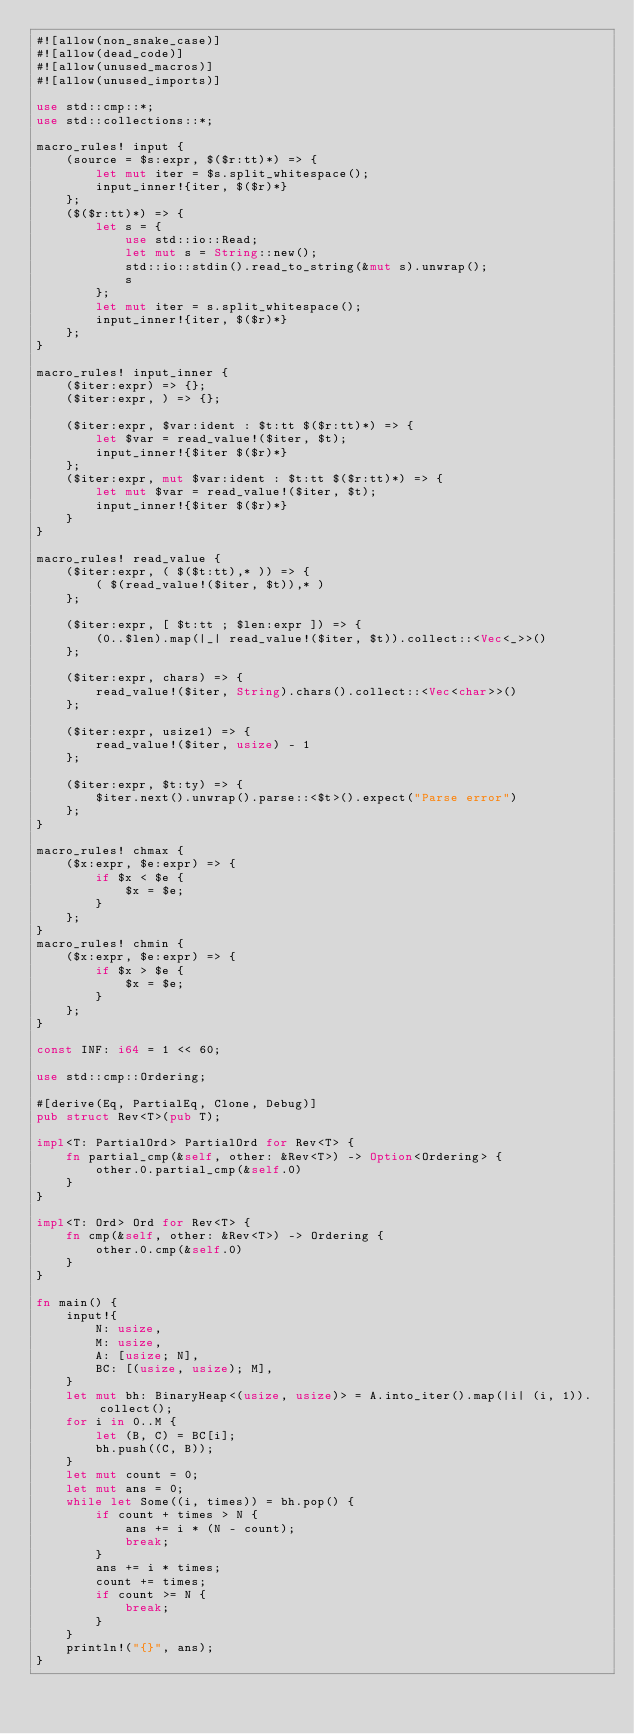<code> <loc_0><loc_0><loc_500><loc_500><_Rust_>#![allow(non_snake_case)]
#![allow(dead_code)]
#![allow(unused_macros)]
#![allow(unused_imports)]

use std::cmp::*;
use std::collections::*;

macro_rules! input {
    (source = $s:expr, $($r:tt)*) => {
        let mut iter = $s.split_whitespace();
        input_inner!{iter, $($r)*}
    };
    ($($r:tt)*) => {
        let s = {
            use std::io::Read;
            let mut s = String::new();
            std::io::stdin().read_to_string(&mut s).unwrap();
            s
        };
        let mut iter = s.split_whitespace();
        input_inner!{iter, $($r)*}
    };
}

macro_rules! input_inner {
    ($iter:expr) => {};
    ($iter:expr, ) => {};

    ($iter:expr, $var:ident : $t:tt $($r:tt)*) => {
        let $var = read_value!($iter, $t);
        input_inner!{$iter $($r)*}
    };
    ($iter:expr, mut $var:ident : $t:tt $($r:tt)*) => {
        let mut $var = read_value!($iter, $t);
        input_inner!{$iter $($r)*}
    }
}

macro_rules! read_value {
    ($iter:expr, ( $($t:tt),* )) => {
        ( $(read_value!($iter, $t)),* )
    };

    ($iter:expr, [ $t:tt ; $len:expr ]) => {
        (0..$len).map(|_| read_value!($iter, $t)).collect::<Vec<_>>()
    };

    ($iter:expr, chars) => {
        read_value!($iter, String).chars().collect::<Vec<char>>()
    };

    ($iter:expr, usize1) => {
        read_value!($iter, usize) - 1
    };

    ($iter:expr, $t:ty) => {
        $iter.next().unwrap().parse::<$t>().expect("Parse error")
    };
}

macro_rules! chmax {
    ($x:expr, $e:expr) => {
        if $x < $e {
            $x = $e;
        }
    };
}
macro_rules! chmin {
    ($x:expr, $e:expr) => {
        if $x > $e {
            $x = $e;
        }
    };
}

const INF: i64 = 1 << 60;

use std::cmp::Ordering;

#[derive(Eq, PartialEq, Clone, Debug)]
pub struct Rev<T>(pub T);

impl<T: PartialOrd> PartialOrd for Rev<T> {
    fn partial_cmp(&self, other: &Rev<T>) -> Option<Ordering> {
        other.0.partial_cmp(&self.0)
    }
}

impl<T: Ord> Ord for Rev<T> {
    fn cmp(&self, other: &Rev<T>) -> Ordering {
        other.0.cmp(&self.0)
    }
}

fn main() {
    input!{
        N: usize,
        M: usize,
        A: [usize; N],
        BC: [(usize, usize); M],
    }
    let mut bh: BinaryHeap<(usize, usize)> = A.into_iter().map(|i| (i, 1)).collect();
    for i in 0..M {
        let (B, C) = BC[i];
        bh.push((C, B));
    }
    let mut count = 0;
    let mut ans = 0;
    while let Some((i, times)) = bh.pop() {
        if count + times > N {
            ans += i * (N - count);
            break;
        }
        ans += i * times;
        count += times;
        if count >= N {
            break;
        }
    }
    println!("{}", ans);
}
</code> 